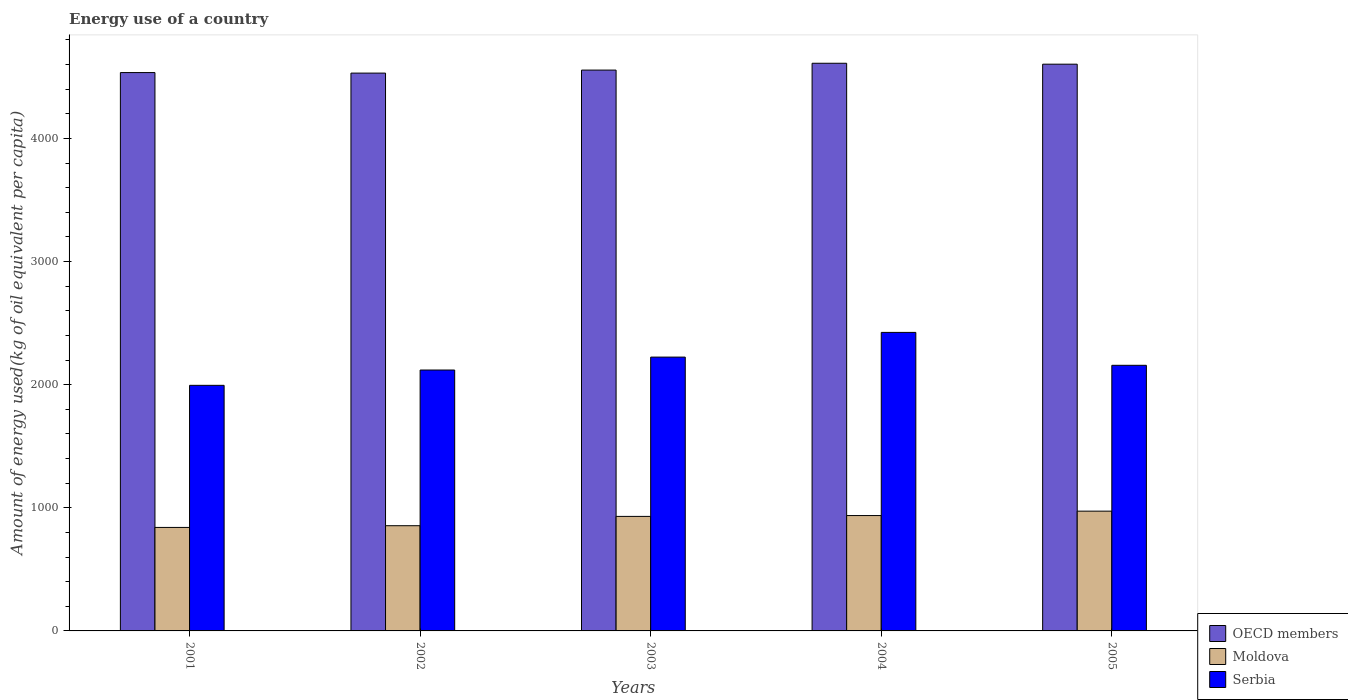How many different coloured bars are there?
Keep it short and to the point. 3. How many groups of bars are there?
Offer a very short reply. 5. Are the number of bars on each tick of the X-axis equal?
Provide a succinct answer. Yes. How many bars are there on the 3rd tick from the left?
Your answer should be very brief. 3. How many bars are there on the 2nd tick from the right?
Your response must be concise. 3. What is the label of the 4th group of bars from the left?
Offer a terse response. 2004. What is the amount of energy used in in OECD members in 2005?
Your answer should be compact. 4602.66. Across all years, what is the maximum amount of energy used in in Serbia?
Keep it short and to the point. 2424.4. Across all years, what is the minimum amount of energy used in in Serbia?
Offer a very short reply. 1994.46. In which year was the amount of energy used in in OECD members maximum?
Make the answer very short. 2004. In which year was the amount of energy used in in OECD members minimum?
Provide a short and direct response. 2002. What is the total amount of energy used in in Serbia in the graph?
Your response must be concise. 1.09e+04. What is the difference between the amount of energy used in in Moldova in 2001 and that in 2003?
Provide a succinct answer. -89.58. What is the difference between the amount of energy used in in OECD members in 2003 and the amount of energy used in in Serbia in 2001?
Provide a succinct answer. 2560.15. What is the average amount of energy used in in OECD members per year?
Give a very brief answer. 4566.41. In the year 2003, what is the difference between the amount of energy used in in Moldova and amount of energy used in in Serbia?
Offer a very short reply. -1293.75. What is the ratio of the amount of energy used in in OECD members in 2001 to that in 2003?
Provide a succinct answer. 1. Is the amount of energy used in in Moldova in 2002 less than that in 2005?
Make the answer very short. Yes. What is the difference between the highest and the second highest amount of energy used in in OECD members?
Offer a terse response. 7.44. What is the difference between the highest and the lowest amount of energy used in in OECD members?
Provide a short and direct response. 79.93. What does the 2nd bar from the right in 2004 represents?
Make the answer very short. Moldova. How many bars are there?
Ensure brevity in your answer.  15. Are all the bars in the graph horizontal?
Provide a succinct answer. No. Are the values on the major ticks of Y-axis written in scientific E-notation?
Offer a terse response. No. Does the graph contain any zero values?
Provide a succinct answer. No. Where does the legend appear in the graph?
Ensure brevity in your answer.  Bottom right. How many legend labels are there?
Provide a succinct answer. 3. What is the title of the graph?
Your answer should be very brief. Energy use of a country. What is the label or title of the Y-axis?
Provide a succinct answer. Amount of energy used(kg of oil equivalent per capita). What is the Amount of energy used(kg of oil equivalent per capita) in OECD members in 2001?
Keep it short and to the point. 4534.5. What is the Amount of energy used(kg of oil equivalent per capita) in Moldova in 2001?
Provide a succinct answer. 840.45. What is the Amount of energy used(kg of oil equivalent per capita) of Serbia in 2001?
Provide a succinct answer. 1994.46. What is the Amount of energy used(kg of oil equivalent per capita) in OECD members in 2002?
Provide a short and direct response. 4530.17. What is the Amount of energy used(kg of oil equivalent per capita) of Moldova in 2002?
Offer a very short reply. 854.42. What is the Amount of energy used(kg of oil equivalent per capita) in Serbia in 2002?
Ensure brevity in your answer.  2118.79. What is the Amount of energy used(kg of oil equivalent per capita) in OECD members in 2003?
Provide a succinct answer. 4554.62. What is the Amount of energy used(kg of oil equivalent per capita) of Moldova in 2003?
Give a very brief answer. 930.03. What is the Amount of energy used(kg of oil equivalent per capita) of Serbia in 2003?
Make the answer very short. 2223.78. What is the Amount of energy used(kg of oil equivalent per capita) of OECD members in 2004?
Your answer should be compact. 4610.1. What is the Amount of energy used(kg of oil equivalent per capita) in Moldova in 2004?
Your answer should be compact. 936.97. What is the Amount of energy used(kg of oil equivalent per capita) of Serbia in 2004?
Offer a terse response. 2424.4. What is the Amount of energy used(kg of oil equivalent per capita) of OECD members in 2005?
Provide a short and direct response. 4602.66. What is the Amount of energy used(kg of oil equivalent per capita) of Moldova in 2005?
Your answer should be very brief. 972.74. What is the Amount of energy used(kg of oil equivalent per capita) of Serbia in 2005?
Ensure brevity in your answer.  2157.16. Across all years, what is the maximum Amount of energy used(kg of oil equivalent per capita) in OECD members?
Offer a terse response. 4610.1. Across all years, what is the maximum Amount of energy used(kg of oil equivalent per capita) of Moldova?
Your answer should be compact. 972.74. Across all years, what is the maximum Amount of energy used(kg of oil equivalent per capita) of Serbia?
Keep it short and to the point. 2424.4. Across all years, what is the minimum Amount of energy used(kg of oil equivalent per capita) of OECD members?
Provide a short and direct response. 4530.17. Across all years, what is the minimum Amount of energy used(kg of oil equivalent per capita) in Moldova?
Ensure brevity in your answer.  840.45. Across all years, what is the minimum Amount of energy used(kg of oil equivalent per capita) of Serbia?
Offer a very short reply. 1994.46. What is the total Amount of energy used(kg of oil equivalent per capita) of OECD members in the graph?
Your answer should be compact. 2.28e+04. What is the total Amount of energy used(kg of oil equivalent per capita) in Moldova in the graph?
Make the answer very short. 4534.6. What is the total Amount of energy used(kg of oil equivalent per capita) in Serbia in the graph?
Make the answer very short. 1.09e+04. What is the difference between the Amount of energy used(kg of oil equivalent per capita) in OECD members in 2001 and that in 2002?
Your answer should be compact. 4.33. What is the difference between the Amount of energy used(kg of oil equivalent per capita) of Moldova in 2001 and that in 2002?
Provide a short and direct response. -13.97. What is the difference between the Amount of energy used(kg of oil equivalent per capita) of Serbia in 2001 and that in 2002?
Make the answer very short. -124.33. What is the difference between the Amount of energy used(kg of oil equivalent per capita) in OECD members in 2001 and that in 2003?
Provide a short and direct response. -20.12. What is the difference between the Amount of energy used(kg of oil equivalent per capita) in Moldova in 2001 and that in 2003?
Provide a short and direct response. -89.58. What is the difference between the Amount of energy used(kg of oil equivalent per capita) of Serbia in 2001 and that in 2003?
Offer a very short reply. -229.32. What is the difference between the Amount of energy used(kg of oil equivalent per capita) in OECD members in 2001 and that in 2004?
Ensure brevity in your answer.  -75.6. What is the difference between the Amount of energy used(kg of oil equivalent per capita) in Moldova in 2001 and that in 2004?
Give a very brief answer. -96.52. What is the difference between the Amount of energy used(kg of oil equivalent per capita) in Serbia in 2001 and that in 2004?
Give a very brief answer. -429.94. What is the difference between the Amount of energy used(kg of oil equivalent per capita) of OECD members in 2001 and that in 2005?
Offer a terse response. -68.16. What is the difference between the Amount of energy used(kg of oil equivalent per capita) of Moldova in 2001 and that in 2005?
Offer a very short reply. -132.29. What is the difference between the Amount of energy used(kg of oil equivalent per capita) in Serbia in 2001 and that in 2005?
Offer a very short reply. -162.7. What is the difference between the Amount of energy used(kg of oil equivalent per capita) in OECD members in 2002 and that in 2003?
Make the answer very short. -24.44. What is the difference between the Amount of energy used(kg of oil equivalent per capita) in Moldova in 2002 and that in 2003?
Offer a very short reply. -75.61. What is the difference between the Amount of energy used(kg of oil equivalent per capita) in Serbia in 2002 and that in 2003?
Keep it short and to the point. -104.99. What is the difference between the Amount of energy used(kg of oil equivalent per capita) of OECD members in 2002 and that in 2004?
Make the answer very short. -79.93. What is the difference between the Amount of energy used(kg of oil equivalent per capita) of Moldova in 2002 and that in 2004?
Make the answer very short. -82.55. What is the difference between the Amount of energy used(kg of oil equivalent per capita) in Serbia in 2002 and that in 2004?
Provide a short and direct response. -305.61. What is the difference between the Amount of energy used(kg of oil equivalent per capita) in OECD members in 2002 and that in 2005?
Give a very brief answer. -72.49. What is the difference between the Amount of energy used(kg of oil equivalent per capita) in Moldova in 2002 and that in 2005?
Your answer should be very brief. -118.32. What is the difference between the Amount of energy used(kg of oil equivalent per capita) in Serbia in 2002 and that in 2005?
Provide a succinct answer. -38.37. What is the difference between the Amount of energy used(kg of oil equivalent per capita) in OECD members in 2003 and that in 2004?
Offer a terse response. -55.48. What is the difference between the Amount of energy used(kg of oil equivalent per capita) of Moldova in 2003 and that in 2004?
Your response must be concise. -6.94. What is the difference between the Amount of energy used(kg of oil equivalent per capita) in Serbia in 2003 and that in 2004?
Your answer should be very brief. -200.62. What is the difference between the Amount of energy used(kg of oil equivalent per capita) in OECD members in 2003 and that in 2005?
Offer a terse response. -48.05. What is the difference between the Amount of energy used(kg of oil equivalent per capita) in Moldova in 2003 and that in 2005?
Your answer should be very brief. -42.71. What is the difference between the Amount of energy used(kg of oil equivalent per capita) of Serbia in 2003 and that in 2005?
Make the answer very short. 66.62. What is the difference between the Amount of energy used(kg of oil equivalent per capita) in OECD members in 2004 and that in 2005?
Provide a succinct answer. 7.44. What is the difference between the Amount of energy used(kg of oil equivalent per capita) in Moldova in 2004 and that in 2005?
Ensure brevity in your answer.  -35.77. What is the difference between the Amount of energy used(kg of oil equivalent per capita) in Serbia in 2004 and that in 2005?
Offer a very short reply. 267.24. What is the difference between the Amount of energy used(kg of oil equivalent per capita) of OECD members in 2001 and the Amount of energy used(kg of oil equivalent per capita) of Moldova in 2002?
Your answer should be very brief. 3680.08. What is the difference between the Amount of energy used(kg of oil equivalent per capita) in OECD members in 2001 and the Amount of energy used(kg of oil equivalent per capita) in Serbia in 2002?
Provide a short and direct response. 2415.71. What is the difference between the Amount of energy used(kg of oil equivalent per capita) in Moldova in 2001 and the Amount of energy used(kg of oil equivalent per capita) in Serbia in 2002?
Offer a very short reply. -1278.34. What is the difference between the Amount of energy used(kg of oil equivalent per capita) in OECD members in 2001 and the Amount of energy used(kg of oil equivalent per capita) in Moldova in 2003?
Provide a succinct answer. 3604.47. What is the difference between the Amount of energy used(kg of oil equivalent per capita) in OECD members in 2001 and the Amount of energy used(kg of oil equivalent per capita) in Serbia in 2003?
Provide a succinct answer. 2310.72. What is the difference between the Amount of energy used(kg of oil equivalent per capita) in Moldova in 2001 and the Amount of energy used(kg of oil equivalent per capita) in Serbia in 2003?
Offer a very short reply. -1383.33. What is the difference between the Amount of energy used(kg of oil equivalent per capita) of OECD members in 2001 and the Amount of energy used(kg of oil equivalent per capita) of Moldova in 2004?
Your response must be concise. 3597.53. What is the difference between the Amount of energy used(kg of oil equivalent per capita) of OECD members in 2001 and the Amount of energy used(kg of oil equivalent per capita) of Serbia in 2004?
Provide a short and direct response. 2110.1. What is the difference between the Amount of energy used(kg of oil equivalent per capita) of Moldova in 2001 and the Amount of energy used(kg of oil equivalent per capita) of Serbia in 2004?
Ensure brevity in your answer.  -1583.95. What is the difference between the Amount of energy used(kg of oil equivalent per capita) of OECD members in 2001 and the Amount of energy used(kg of oil equivalent per capita) of Moldova in 2005?
Ensure brevity in your answer.  3561.76. What is the difference between the Amount of energy used(kg of oil equivalent per capita) in OECD members in 2001 and the Amount of energy used(kg of oil equivalent per capita) in Serbia in 2005?
Your answer should be compact. 2377.34. What is the difference between the Amount of energy used(kg of oil equivalent per capita) of Moldova in 2001 and the Amount of energy used(kg of oil equivalent per capita) of Serbia in 2005?
Give a very brief answer. -1316.71. What is the difference between the Amount of energy used(kg of oil equivalent per capita) in OECD members in 2002 and the Amount of energy used(kg of oil equivalent per capita) in Moldova in 2003?
Provide a short and direct response. 3600.14. What is the difference between the Amount of energy used(kg of oil equivalent per capita) of OECD members in 2002 and the Amount of energy used(kg of oil equivalent per capita) of Serbia in 2003?
Offer a terse response. 2306.39. What is the difference between the Amount of energy used(kg of oil equivalent per capita) of Moldova in 2002 and the Amount of energy used(kg of oil equivalent per capita) of Serbia in 2003?
Give a very brief answer. -1369.36. What is the difference between the Amount of energy used(kg of oil equivalent per capita) of OECD members in 2002 and the Amount of energy used(kg of oil equivalent per capita) of Moldova in 2004?
Ensure brevity in your answer.  3593.21. What is the difference between the Amount of energy used(kg of oil equivalent per capita) in OECD members in 2002 and the Amount of energy used(kg of oil equivalent per capita) in Serbia in 2004?
Your answer should be compact. 2105.77. What is the difference between the Amount of energy used(kg of oil equivalent per capita) in Moldova in 2002 and the Amount of energy used(kg of oil equivalent per capita) in Serbia in 2004?
Your answer should be very brief. -1569.99. What is the difference between the Amount of energy used(kg of oil equivalent per capita) in OECD members in 2002 and the Amount of energy used(kg of oil equivalent per capita) in Moldova in 2005?
Provide a short and direct response. 3557.43. What is the difference between the Amount of energy used(kg of oil equivalent per capita) in OECD members in 2002 and the Amount of energy used(kg of oil equivalent per capita) in Serbia in 2005?
Give a very brief answer. 2373.01. What is the difference between the Amount of energy used(kg of oil equivalent per capita) of Moldova in 2002 and the Amount of energy used(kg of oil equivalent per capita) of Serbia in 2005?
Your response must be concise. -1302.74. What is the difference between the Amount of energy used(kg of oil equivalent per capita) in OECD members in 2003 and the Amount of energy used(kg of oil equivalent per capita) in Moldova in 2004?
Offer a terse response. 3617.65. What is the difference between the Amount of energy used(kg of oil equivalent per capita) in OECD members in 2003 and the Amount of energy used(kg of oil equivalent per capita) in Serbia in 2004?
Ensure brevity in your answer.  2130.21. What is the difference between the Amount of energy used(kg of oil equivalent per capita) of Moldova in 2003 and the Amount of energy used(kg of oil equivalent per capita) of Serbia in 2004?
Ensure brevity in your answer.  -1494.38. What is the difference between the Amount of energy used(kg of oil equivalent per capita) of OECD members in 2003 and the Amount of energy used(kg of oil equivalent per capita) of Moldova in 2005?
Your answer should be compact. 3581.88. What is the difference between the Amount of energy used(kg of oil equivalent per capita) of OECD members in 2003 and the Amount of energy used(kg of oil equivalent per capita) of Serbia in 2005?
Offer a very short reply. 2397.45. What is the difference between the Amount of energy used(kg of oil equivalent per capita) in Moldova in 2003 and the Amount of energy used(kg of oil equivalent per capita) in Serbia in 2005?
Keep it short and to the point. -1227.13. What is the difference between the Amount of energy used(kg of oil equivalent per capita) of OECD members in 2004 and the Amount of energy used(kg of oil equivalent per capita) of Moldova in 2005?
Provide a succinct answer. 3637.36. What is the difference between the Amount of energy used(kg of oil equivalent per capita) of OECD members in 2004 and the Amount of energy used(kg of oil equivalent per capita) of Serbia in 2005?
Provide a succinct answer. 2452.94. What is the difference between the Amount of energy used(kg of oil equivalent per capita) in Moldova in 2004 and the Amount of energy used(kg of oil equivalent per capita) in Serbia in 2005?
Your answer should be very brief. -1220.2. What is the average Amount of energy used(kg of oil equivalent per capita) in OECD members per year?
Offer a terse response. 4566.41. What is the average Amount of energy used(kg of oil equivalent per capita) of Moldova per year?
Ensure brevity in your answer.  906.92. What is the average Amount of energy used(kg of oil equivalent per capita) in Serbia per year?
Offer a terse response. 2183.72. In the year 2001, what is the difference between the Amount of energy used(kg of oil equivalent per capita) of OECD members and Amount of energy used(kg of oil equivalent per capita) of Moldova?
Provide a short and direct response. 3694.05. In the year 2001, what is the difference between the Amount of energy used(kg of oil equivalent per capita) in OECD members and Amount of energy used(kg of oil equivalent per capita) in Serbia?
Provide a short and direct response. 2540.04. In the year 2001, what is the difference between the Amount of energy used(kg of oil equivalent per capita) in Moldova and Amount of energy used(kg of oil equivalent per capita) in Serbia?
Your response must be concise. -1154.01. In the year 2002, what is the difference between the Amount of energy used(kg of oil equivalent per capita) in OECD members and Amount of energy used(kg of oil equivalent per capita) in Moldova?
Offer a very short reply. 3675.75. In the year 2002, what is the difference between the Amount of energy used(kg of oil equivalent per capita) of OECD members and Amount of energy used(kg of oil equivalent per capita) of Serbia?
Provide a succinct answer. 2411.38. In the year 2002, what is the difference between the Amount of energy used(kg of oil equivalent per capita) of Moldova and Amount of energy used(kg of oil equivalent per capita) of Serbia?
Provide a succinct answer. -1264.37. In the year 2003, what is the difference between the Amount of energy used(kg of oil equivalent per capita) in OECD members and Amount of energy used(kg of oil equivalent per capita) in Moldova?
Provide a succinct answer. 3624.59. In the year 2003, what is the difference between the Amount of energy used(kg of oil equivalent per capita) of OECD members and Amount of energy used(kg of oil equivalent per capita) of Serbia?
Ensure brevity in your answer.  2330.83. In the year 2003, what is the difference between the Amount of energy used(kg of oil equivalent per capita) of Moldova and Amount of energy used(kg of oil equivalent per capita) of Serbia?
Your answer should be very brief. -1293.75. In the year 2004, what is the difference between the Amount of energy used(kg of oil equivalent per capita) of OECD members and Amount of energy used(kg of oil equivalent per capita) of Moldova?
Make the answer very short. 3673.13. In the year 2004, what is the difference between the Amount of energy used(kg of oil equivalent per capita) of OECD members and Amount of energy used(kg of oil equivalent per capita) of Serbia?
Make the answer very short. 2185.7. In the year 2004, what is the difference between the Amount of energy used(kg of oil equivalent per capita) of Moldova and Amount of energy used(kg of oil equivalent per capita) of Serbia?
Ensure brevity in your answer.  -1487.44. In the year 2005, what is the difference between the Amount of energy used(kg of oil equivalent per capita) in OECD members and Amount of energy used(kg of oil equivalent per capita) in Moldova?
Your answer should be very brief. 3629.92. In the year 2005, what is the difference between the Amount of energy used(kg of oil equivalent per capita) of OECD members and Amount of energy used(kg of oil equivalent per capita) of Serbia?
Make the answer very short. 2445.5. In the year 2005, what is the difference between the Amount of energy used(kg of oil equivalent per capita) of Moldova and Amount of energy used(kg of oil equivalent per capita) of Serbia?
Ensure brevity in your answer.  -1184.42. What is the ratio of the Amount of energy used(kg of oil equivalent per capita) of Moldova in 2001 to that in 2002?
Give a very brief answer. 0.98. What is the ratio of the Amount of energy used(kg of oil equivalent per capita) of Serbia in 2001 to that in 2002?
Keep it short and to the point. 0.94. What is the ratio of the Amount of energy used(kg of oil equivalent per capita) in OECD members in 2001 to that in 2003?
Provide a short and direct response. 1. What is the ratio of the Amount of energy used(kg of oil equivalent per capita) of Moldova in 2001 to that in 2003?
Ensure brevity in your answer.  0.9. What is the ratio of the Amount of energy used(kg of oil equivalent per capita) in Serbia in 2001 to that in 2003?
Your answer should be compact. 0.9. What is the ratio of the Amount of energy used(kg of oil equivalent per capita) of OECD members in 2001 to that in 2004?
Provide a succinct answer. 0.98. What is the ratio of the Amount of energy used(kg of oil equivalent per capita) in Moldova in 2001 to that in 2004?
Provide a short and direct response. 0.9. What is the ratio of the Amount of energy used(kg of oil equivalent per capita) of Serbia in 2001 to that in 2004?
Ensure brevity in your answer.  0.82. What is the ratio of the Amount of energy used(kg of oil equivalent per capita) of OECD members in 2001 to that in 2005?
Provide a succinct answer. 0.99. What is the ratio of the Amount of energy used(kg of oil equivalent per capita) in Moldova in 2001 to that in 2005?
Provide a succinct answer. 0.86. What is the ratio of the Amount of energy used(kg of oil equivalent per capita) of Serbia in 2001 to that in 2005?
Offer a terse response. 0.92. What is the ratio of the Amount of energy used(kg of oil equivalent per capita) in OECD members in 2002 to that in 2003?
Provide a short and direct response. 0.99. What is the ratio of the Amount of energy used(kg of oil equivalent per capita) in Moldova in 2002 to that in 2003?
Ensure brevity in your answer.  0.92. What is the ratio of the Amount of energy used(kg of oil equivalent per capita) in Serbia in 2002 to that in 2003?
Provide a succinct answer. 0.95. What is the ratio of the Amount of energy used(kg of oil equivalent per capita) of OECD members in 2002 to that in 2004?
Provide a short and direct response. 0.98. What is the ratio of the Amount of energy used(kg of oil equivalent per capita) of Moldova in 2002 to that in 2004?
Make the answer very short. 0.91. What is the ratio of the Amount of energy used(kg of oil equivalent per capita) of Serbia in 2002 to that in 2004?
Provide a succinct answer. 0.87. What is the ratio of the Amount of energy used(kg of oil equivalent per capita) in OECD members in 2002 to that in 2005?
Give a very brief answer. 0.98. What is the ratio of the Amount of energy used(kg of oil equivalent per capita) in Moldova in 2002 to that in 2005?
Your response must be concise. 0.88. What is the ratio of the Amount of energy used(kg of oil equivalent per capita) in Serbia in 2002 to that in 2005?
Keep it short and to the point. 0.98. What is the ratio of the Amount of energy used(kg of oil equivalent per capita) in Moldova in 2003 to that in 2004?
Give a very brief answer. 0.99. What is the ratio of the Amount of energy used(kg of oil equivalent per capita) of Serbia in 2003 to that in 2004?
Offer a very short reply. 0.92. What is the ratio of the Amount of energy used(kg of oil equivalent per capita) in Moldova in 2003 to that in 2005?
Make the answer very short. 0.96. What is the ratio of the Amount of energy used(kg of oil equivalent per capita) of Serbia in 2003 to that in 2005?
Keep it short and to the point. 1.03. What is the ratio of the Amount of energy used(kg of oil equivalent per capita) in OECD members in 2004 to that in 2005?
Offer a terse response. 1. What is the ratio of the Amount of energy used(kg of oil equivalent per capita) in Moldova in 2004 to that in 2005?
Give a very brief answer. 0.96. What is the ratio of the Amount of energy used(kg of oil equivalent per capita) in Serbia in 2004 to that in 2005?
Provide a succinct answer. 1.12. What is the difference between the highest and the second highest Amount of energy used(kg of oil equivalent per capita) in OECD members?
Keep it short and to the point. 7.44. What is the difference between the highest and the second highest Amount of energy used(kg of oil equivalent per capita) of Moldova?
Offer a terse response. 35.77. What is the difference between the highest and the second highest Amount of energy used(kg of oil equivalent per capita) of Serbia?
Offer a terse response. 200.62. What is the difference between the highest and the lowest Amount of energy used(kg of oil equivalent per capita) in OECD members?
Provide a short and direct response. 79.93. What is the difference between the highest and the lowest Amount of energy used(kg of oil equivalent per capita) of Moldova?
Your answer should be very brief. 132.29. What is the difference between the highest and the lowest Amount of energy used(kg of oil equivalent per capita) of Serbia?
Keep it short and to the point. 429.94. 